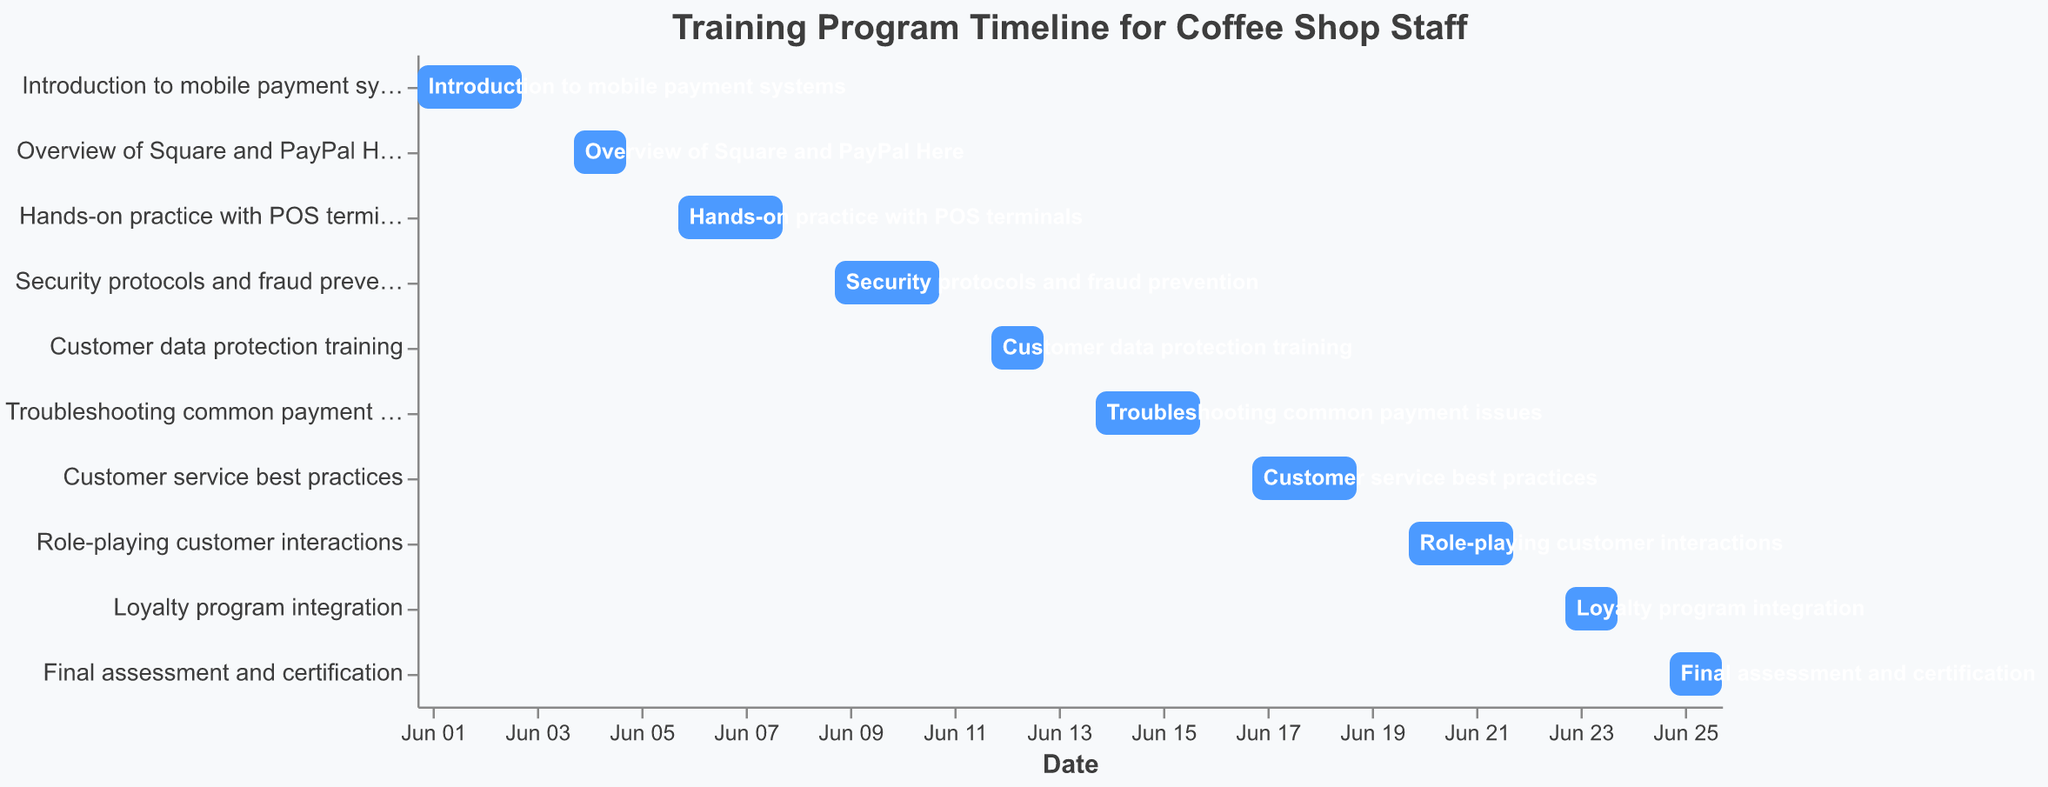What is the title of the chart? The title of the chart is found at the top of the figure and reads "Training Program Timeline for Coffee Shop Staff."
Answer: Training Program Timeline for Coffee Shop Staff What is the time span of the entire training program? The time span is determined by looking at the start date of the first task and the end date of the last task. The first task starts on June 1, 2023, and the last task ends on June 26, 2023.
Answer: 26 days What task takes the longest time to complete? On the Gantt chart, identify the task with the longest bar, which is "Role-playing customer interactions" taking place from June 20 to June 22.
Answer: Role-playing customer interactions How many days is "Hands-on practice with POS terminals" scheduled for? Check the start and end dates for the task "Hands-on practice with POS terminals." It starts on June 6 and ends on June 8, spanning 3 days.
Answer: 3 days Which tasks have the shortest duration, and what are they about? Look for the tasks with the shortest bars. Both "Overview of Square and PayPal Here" and "Loyalty program integration" are the shortest, each spanning 2 days.
Answer: Overview of Square and PayPal Here; Loyalty program integration What is the total number of tasks in the training program? Count the number of distinct tasks listed in the chart. There are 10 tasks.
Answer: 10 tasks When does the "Security protocols and fraud prevention" training start and end? Refer to the position of "Security protocols and fraud prevention." It starts on June 9 and ends on June 11.
Answer: June 9 to June 11 Which task directly follows the "Customer service best practices" training? Look at the order of tasks on the Gantt chart. "Role-playing customer interactions" follows "Customer service best practices."
Answer: Role-playing customer interactions Compare the duration of "Introduction to mobile payment systems" and "Final assessment and certification." Which one is longer? Check the start and end dates of both tasks. "Introduction to mobile payment systems" is from June 1 to June 3 (3 days), and "Final assessment and certification" is from June 25 to June 26 (2 days).
Answer: Introduction to mobile payment systems How many tasks include customer interactions as part of their training? Identify tasks that explicitly mention customer interactions: "Customer service best practices" and "Role-playing customer interactions."
Answer: 2 tasks 